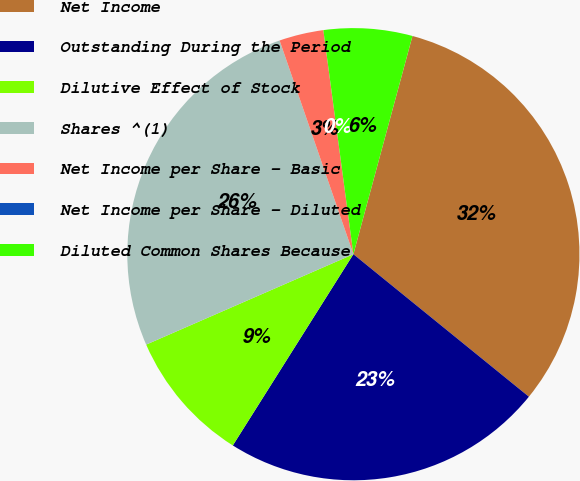Convert chart to OTSL. <chart><loc_0><loc_0><loc_500><loc_500><pie_chart><fcel>Net Income<fcel>Outstanding During the Period<fcel>Dilutive Effect of Stock<fcel>Shares ^(1)<fcel>Net Income per Share - Basic<fcel>Net Income per Share - Diluted<fcel>Diluted Common Shares Because<nl><fcel>31.65%<fcel>23.1%<fcel>9.5%<fcel>26.26%<fcel>3.17%<fcel>0.0%<fcel>6.33%<nl></chart> 